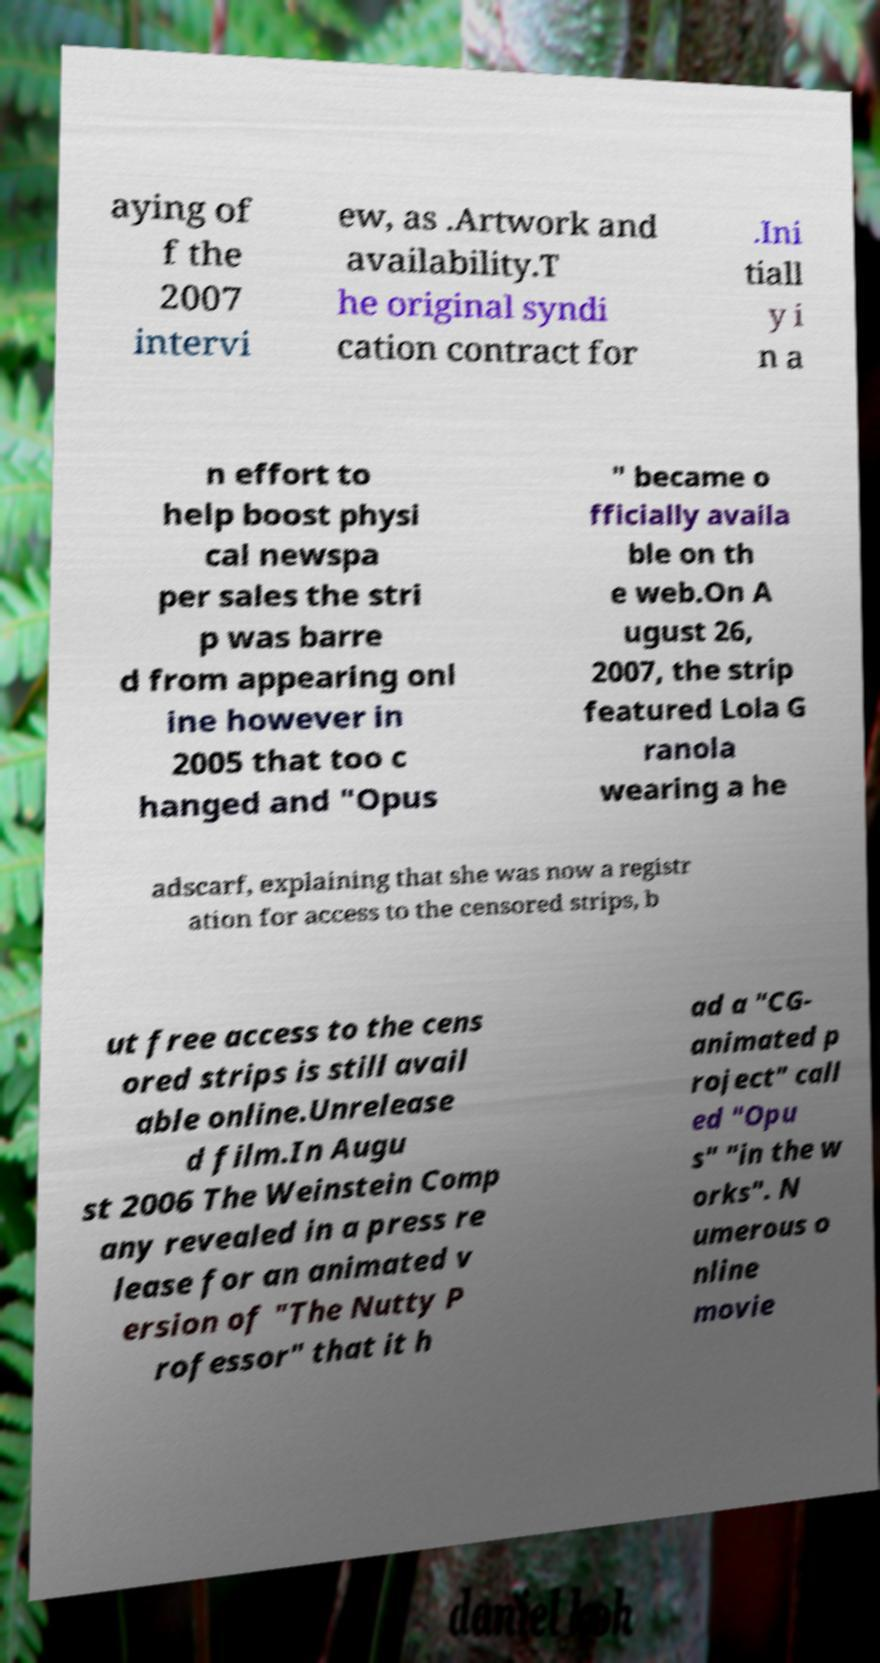For documentation purposes, I need the text within this image transcribed. Could you provide that? aying of f the 2007 intervi ew, as .Artwork and availability.T he original syndi cation contract for .Ini tiall y i n a n effort to help boost physi cal newspa per sales the stri p was barre d from appearing onl ine however in 2005 that too c hanged and "Opus " became o fficially availa ble on th e web.On A ugust 26, 2007, the strip featured Lola G ranola wearing a he adscarf, explaining that she was now a registr ation for access to the censored strips, b ut free access to the cens ored strips is still avail able online.Unrelease d film.In Augu st 2006 The Weinstein Comp any revealed in a press re lease for an animated v ersion of "The Nutty P rofessor" that it h ad a "CG- animated p roject" call ed "Opu s" "in the w orks". N umerous o nline movie 